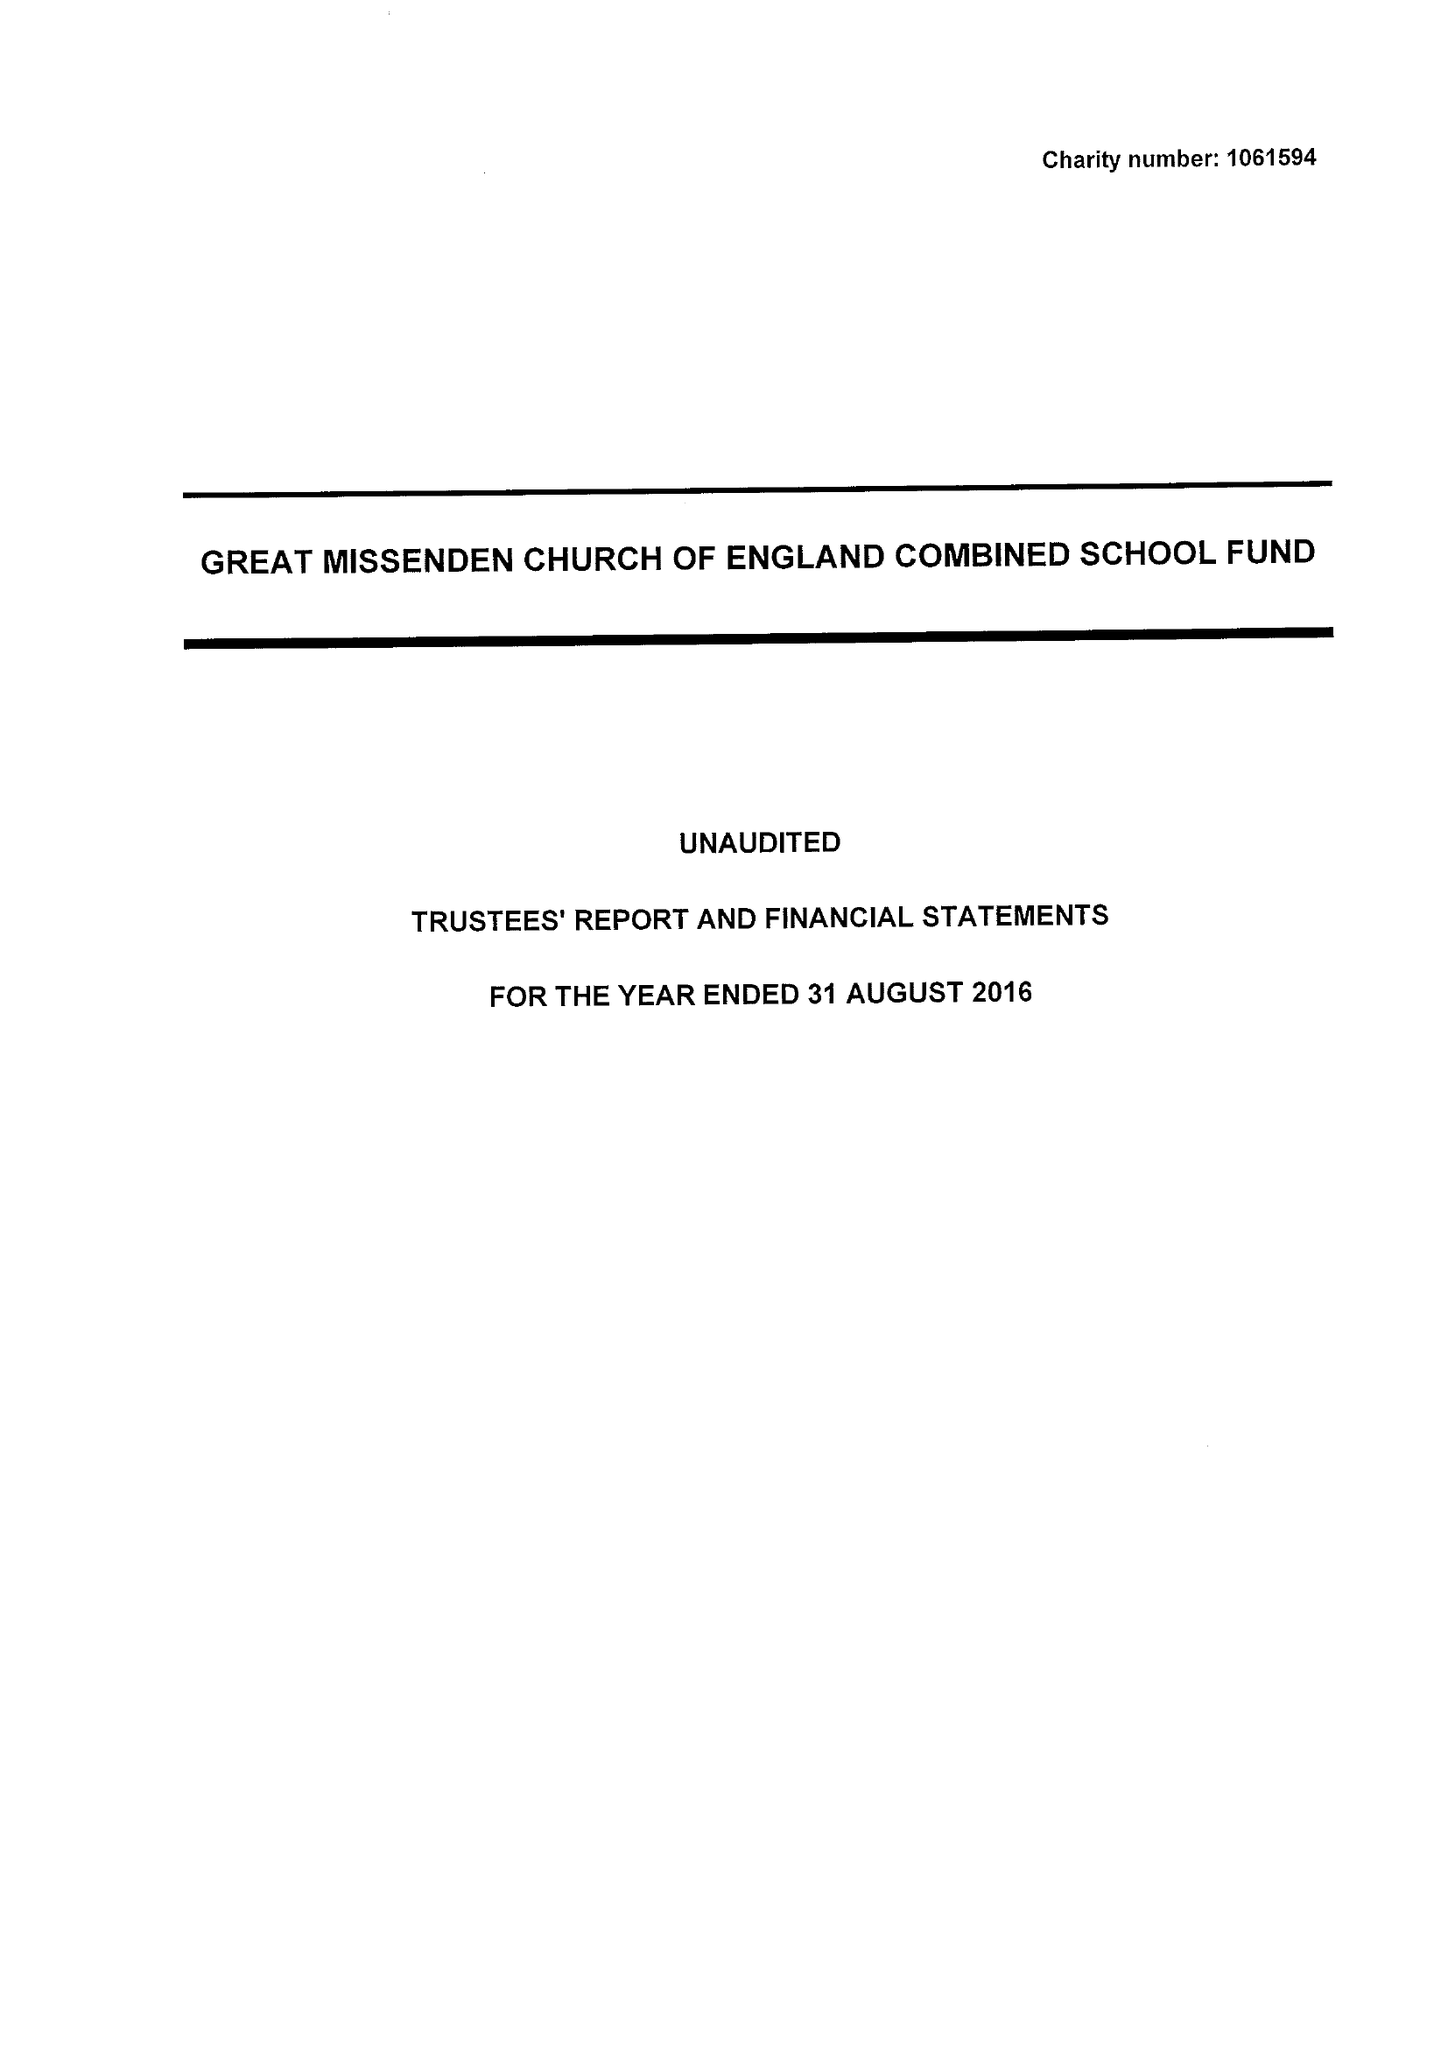What is the value for the address__postcode?
Answer the question using a single word or phrase. HP16 0AZ 